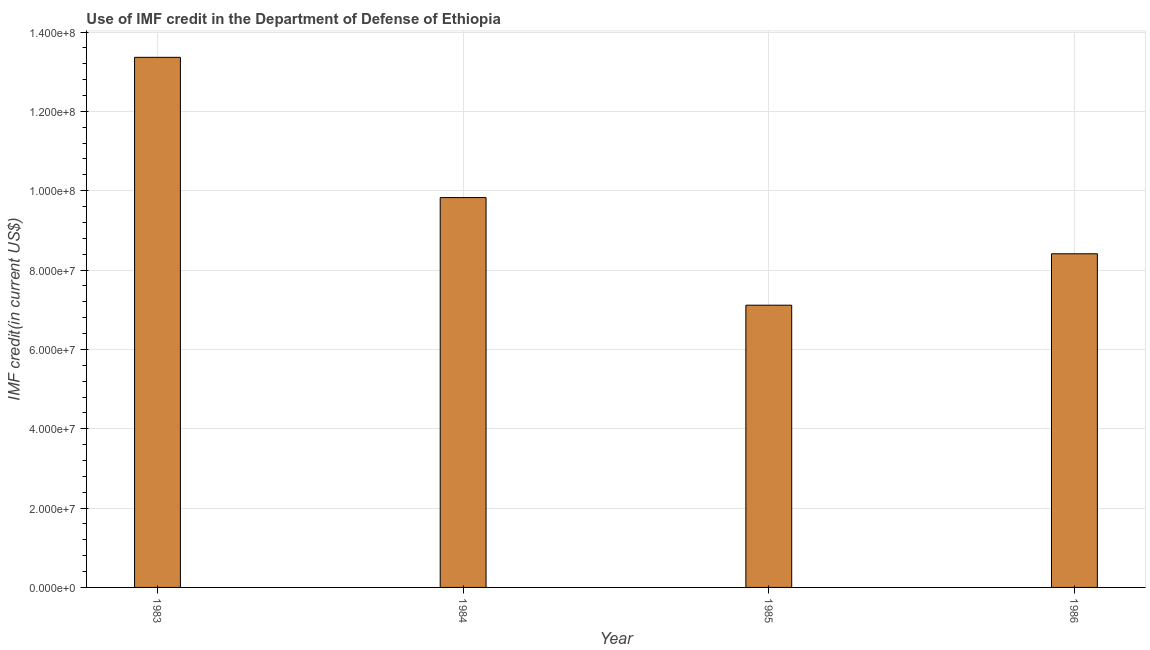What is the title of the graph?
Your answer should be compact. Use of IMF credit in the Department of Defense of Ethiopia. What is the label or title of the X-axis?
Your response must be concise. Year. What is the label or title of the Y-axis?
Offer a terse response. IMF credit(in current US$). What is the use of imf credit in dod in 1984?
Offer a terse response. 9.83e+07. Across all years, what is the maximum use of imf credit in dod?
Provide a succinct answer. 1.34e+08. Across all years, what is the minimum use of imf credit in dod?
Your answer should be very brief. 7.11e+07. In which year was the use of imf credit in dod minimum?
Keep it short and to the point. 1985. What is the sum of the use of imf credit in dod?
Provide a short and direct response. 3.87e+08. What is the difference between the use of imf credit in dod in 1983 and 1985?
Give a very brief answer. 6.25e+07. What is the average use of imf credit in dod per year?
Provide a succinct answer. 9.68e+07. What is the median use of imf credit in dod?
Keep it short and to the point. 9.12e+07. In how many years, is the use of imf credit in dod greater than 8000000 US$?
Keep it short and to the point. 4. Do a majority of the years between 1986 and 1983 (inclusive) have use of imf credit in dod greater than 116000000 US$?
Your answer should be compact. Yes. What is the ratio of the use of imf credit in dod in 1984 to that in 1985?
Ensure brevity in your answer.  1.38. Is the use of imf credit in dod in 1985 less than that in 1986?
Give a very brief answer. Yes. What is the difference between the highest and the second highest use of imf credit in dod?
Provide a succinct answer. 3.54e+07. Is the sum of the use of imf credit in dod in 1983 and 1985 greater than the maximum use of imf credit in dod across all years?
Make the answer very short. Yes. What is the difference between the highest and the lowest use of imf credit in dod?
Keep it short and to the point. 6.25e+07. Are all the bars in the graph horizontal?
Provide a succinct answer. No. What is the IMF credit(in current US$) of 1983?
Your answer should be very brief. 1.34e+08. What is the IMF credit(in current US$) in 1984?
Keep it short and to the point. 9.83e+07. What is the IMF credit(in current US$) in 1985?
Keep it short and to the point. 7.11e+07. What is the IMF credit(in current US$) in 1986?
Provide a short and direct response. 8.41e+07. What is the difference between the IMF credit(in current US$) in 1983 and 1984?
Keep it short and to the point. 3.54e+07. What is the difference between the IMF credit(in current US$) in 1983 and 1985?
Ensure brevity in your answer.  6.25e+07. What is the difference between the IMF credit(in current US$) in 1983 and 1986?
Provide a succinct answer. 4.95e+07. What is the difference between the IMF credit(in current US$) in 1984 and 1985?
Ensure brevity in your answer.  2.71e+07. What is the difference between the IMF credit(in current US$) in 1984 and 1986?
Keep it short and to the point. 1.42e+07. What is the difference between the IMF credit(in current US$) in 1985 and 1986?
Offer a terse response. -1.30e+07. What is the ratio of the IMF credit(in current US$) in 1983 to that in 1984?
Your response must be concise. 1.36. What is the ratio of the IMF credit(in current US$) in 1983 to that in 1985?
Offer a terse response. 1.88. What is the ratio of the IMF credit(in current US$) in 1983 to that in 1986?
Provide a short and direct response. 1.59. What is the ratio of the IMF credit(in current US$) in 1984 to that in 1985?
Provide a short and direct response. 1.38. What is the ratio of the IMF credit(in current US$) in 1984 to that in 1986?
Make the answer very short. 1.17. What is the ratio of the IMF credit(in current US$) in 1985 to that in 1986?
Offer a terse response. 0.85. 